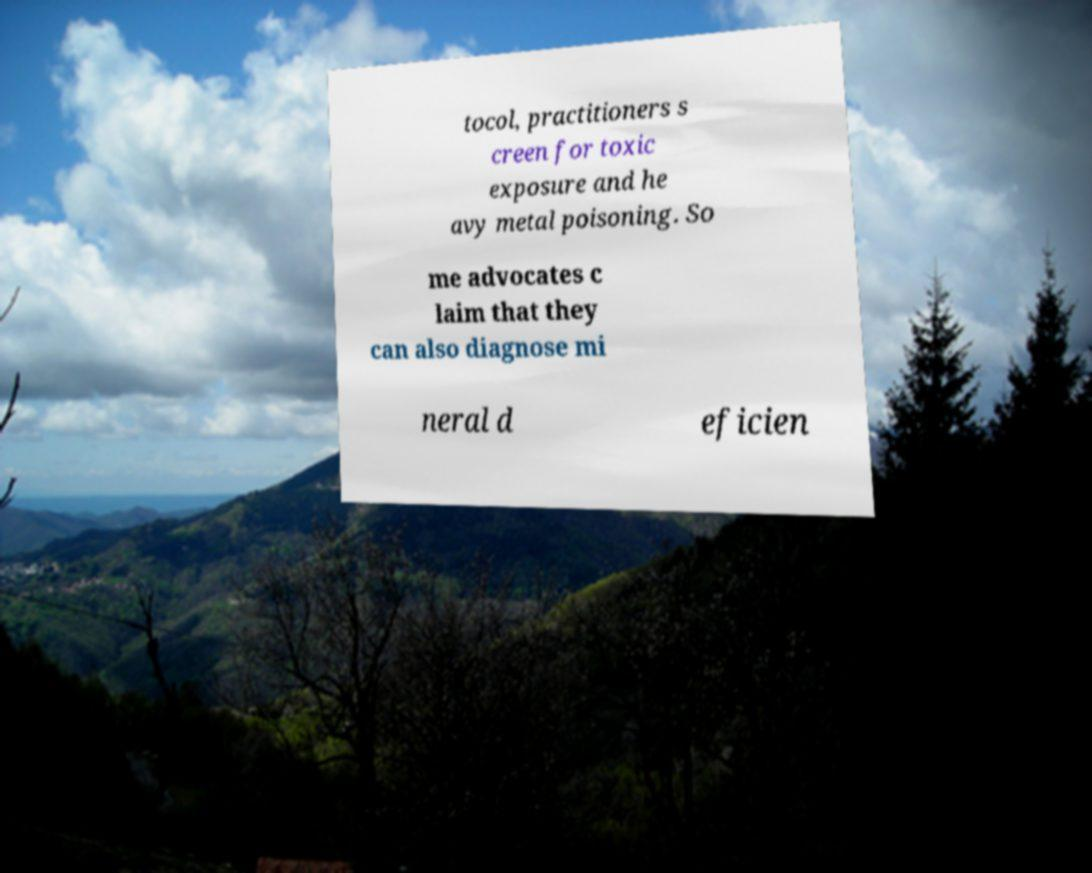Could you extract and type out the text from this image? tocol, practitioners s creen for toxic exposure and he avy metal poisoning. So me advocates c laim that they can also diagnose mi neral d eficien 